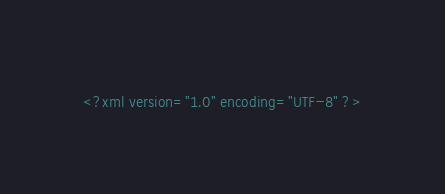Convert code to text. <code><loc_0><loc_0><loc_500><loc_500><_XML_><?xml version="1.0" encoding="UTF-8" ?></code> 